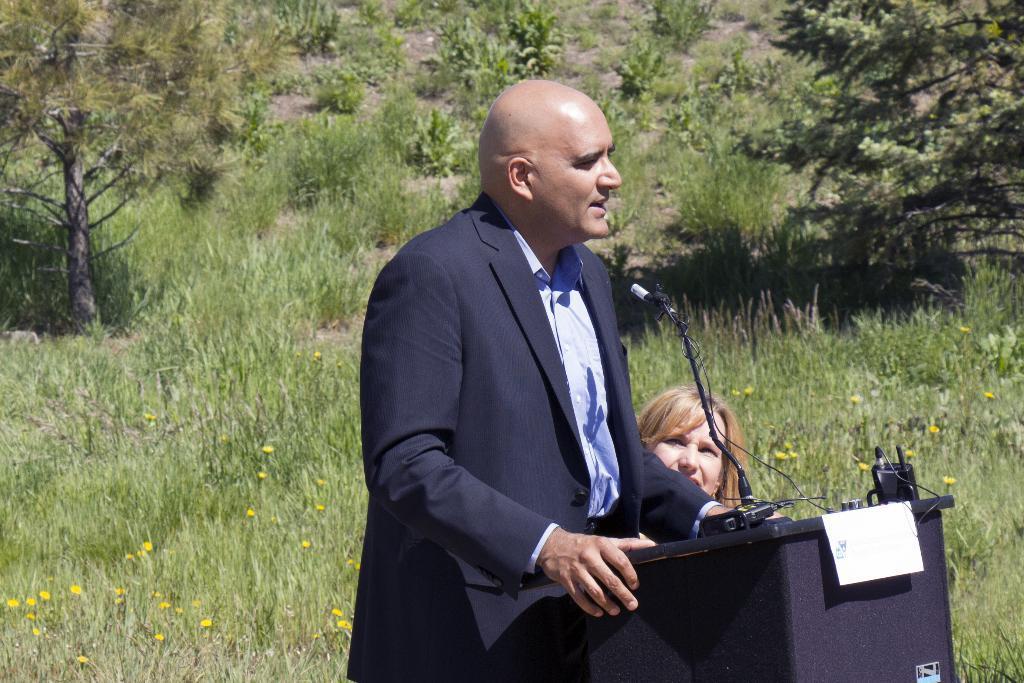Describe this image in one or two sentences. This picture shows a man standing at a podium and speaking with the help of a microphone and we see a woman on the side and we see a paper to the podium and we see grass on the ground and trees and few plants on the ground. 